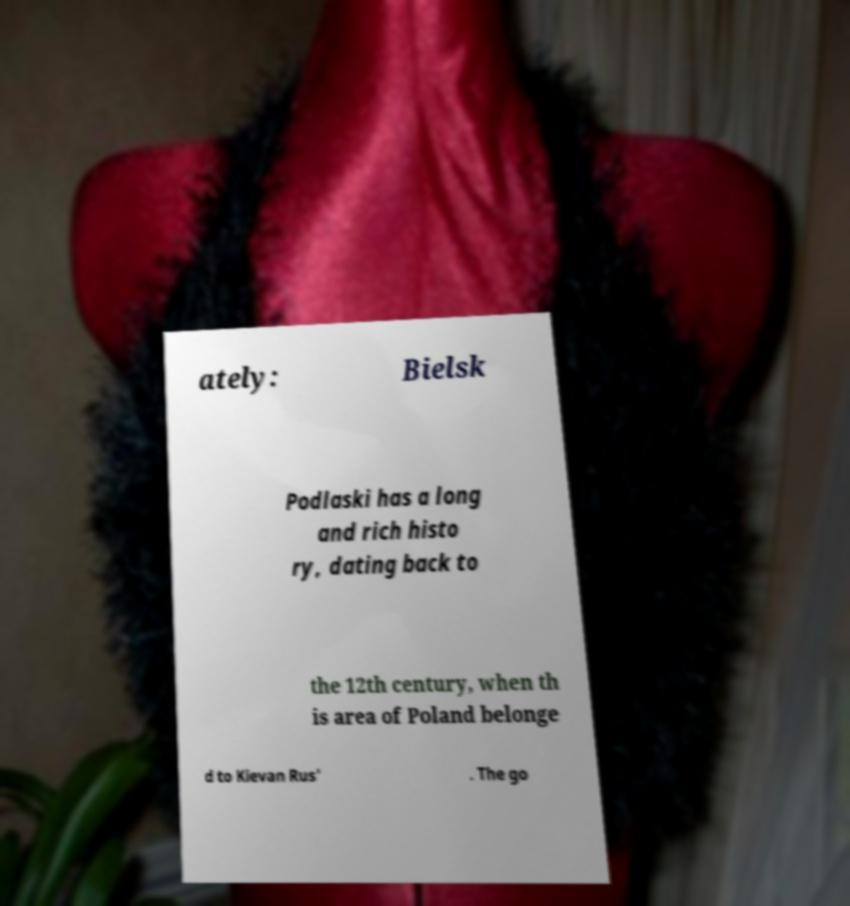I need the written content from this picture converted into text. Can you do that? ately: Bielsk Podlaski has a long and rich histo ry, dating back to the 12th century, when th is area of Poland belonge d to Kievan Rus' . The go 